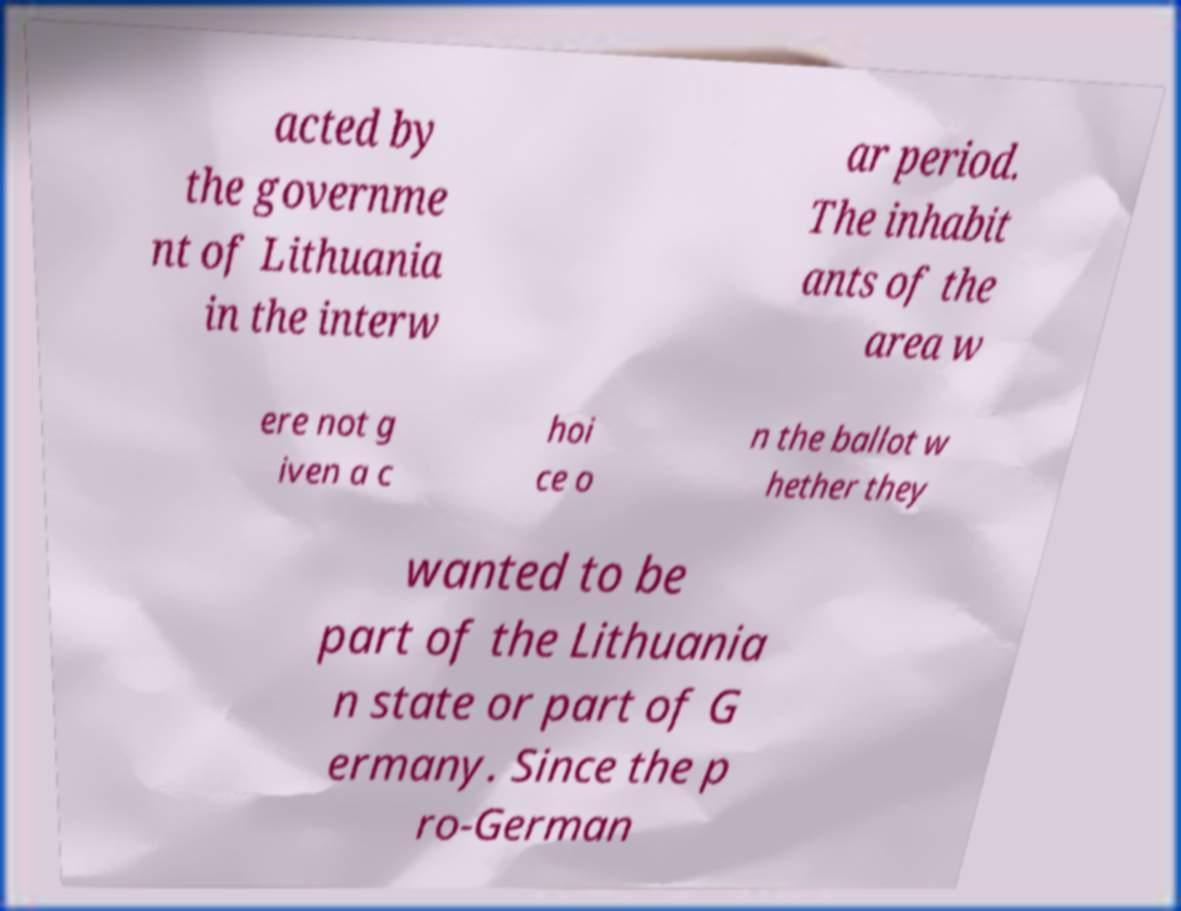Could you extract and type out the text from this image? acted by the governme nt of Lithuania in the interw ar period. The inhabit ants of the area w ere not g iven a c hoi ce o n the ballot w hether they wanted to be part of the Lithuania n state or part of G ermany. Since the p ro-German 